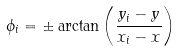Convert formula to latex. <formula><loc_0><loc_0><loc_500><loc_500>\phi _ { i } = \pm \arctan \left ( \frac { y _ { i } - y } { x _ { i } - x } \right )</formula> 